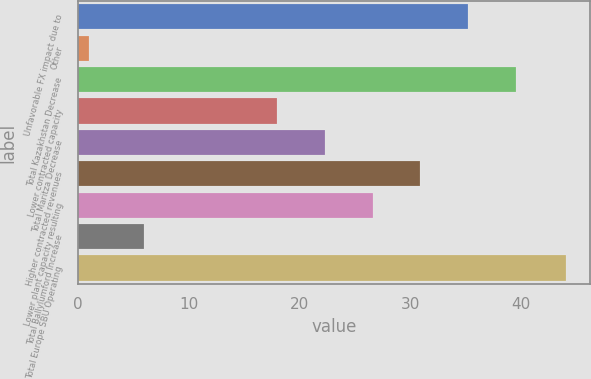Convert chart to OTSL. <chart><loc_0><loc_0><loc_500><loc_500><bar_chart><fcel>Unfavorable FX impact due to<fcel>Other<fcel>Total Kazakhstan Decrease<fcel>Lower contracted capacity<fcel>Total Maritza Decrease<fcel>Higher contracted revenues<fcel>Lower plant capacity resulting<fcel>Total Ballylumford Increase<fcel>Total Europe SBU Operating<nl><fcel>35.2<fcel>1<fcel>39.5<fcel>18<fcel>22.3<fcel>30.9<fcel>26.6<fcel>6<fcel>44<nl></chart> 